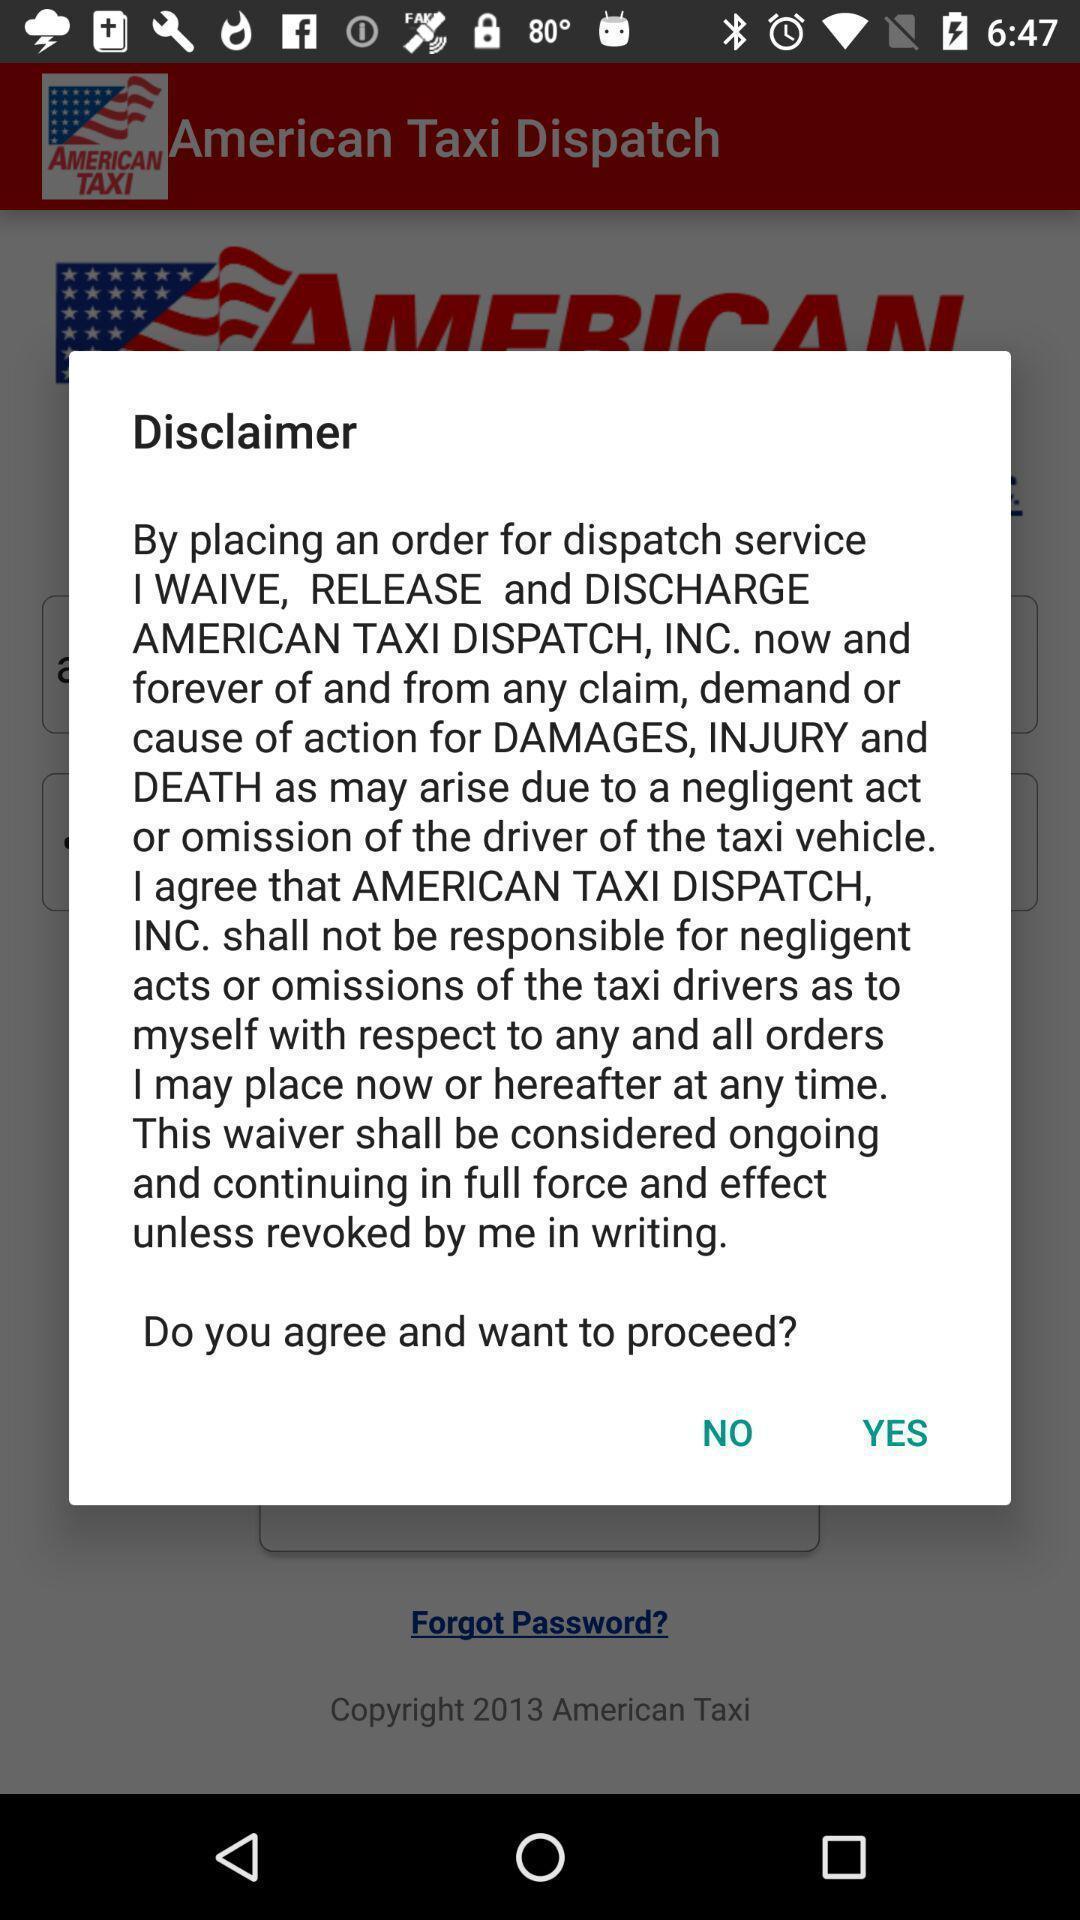Give me a summary of this screen capture. Pop-up displaying the disclaimer. 